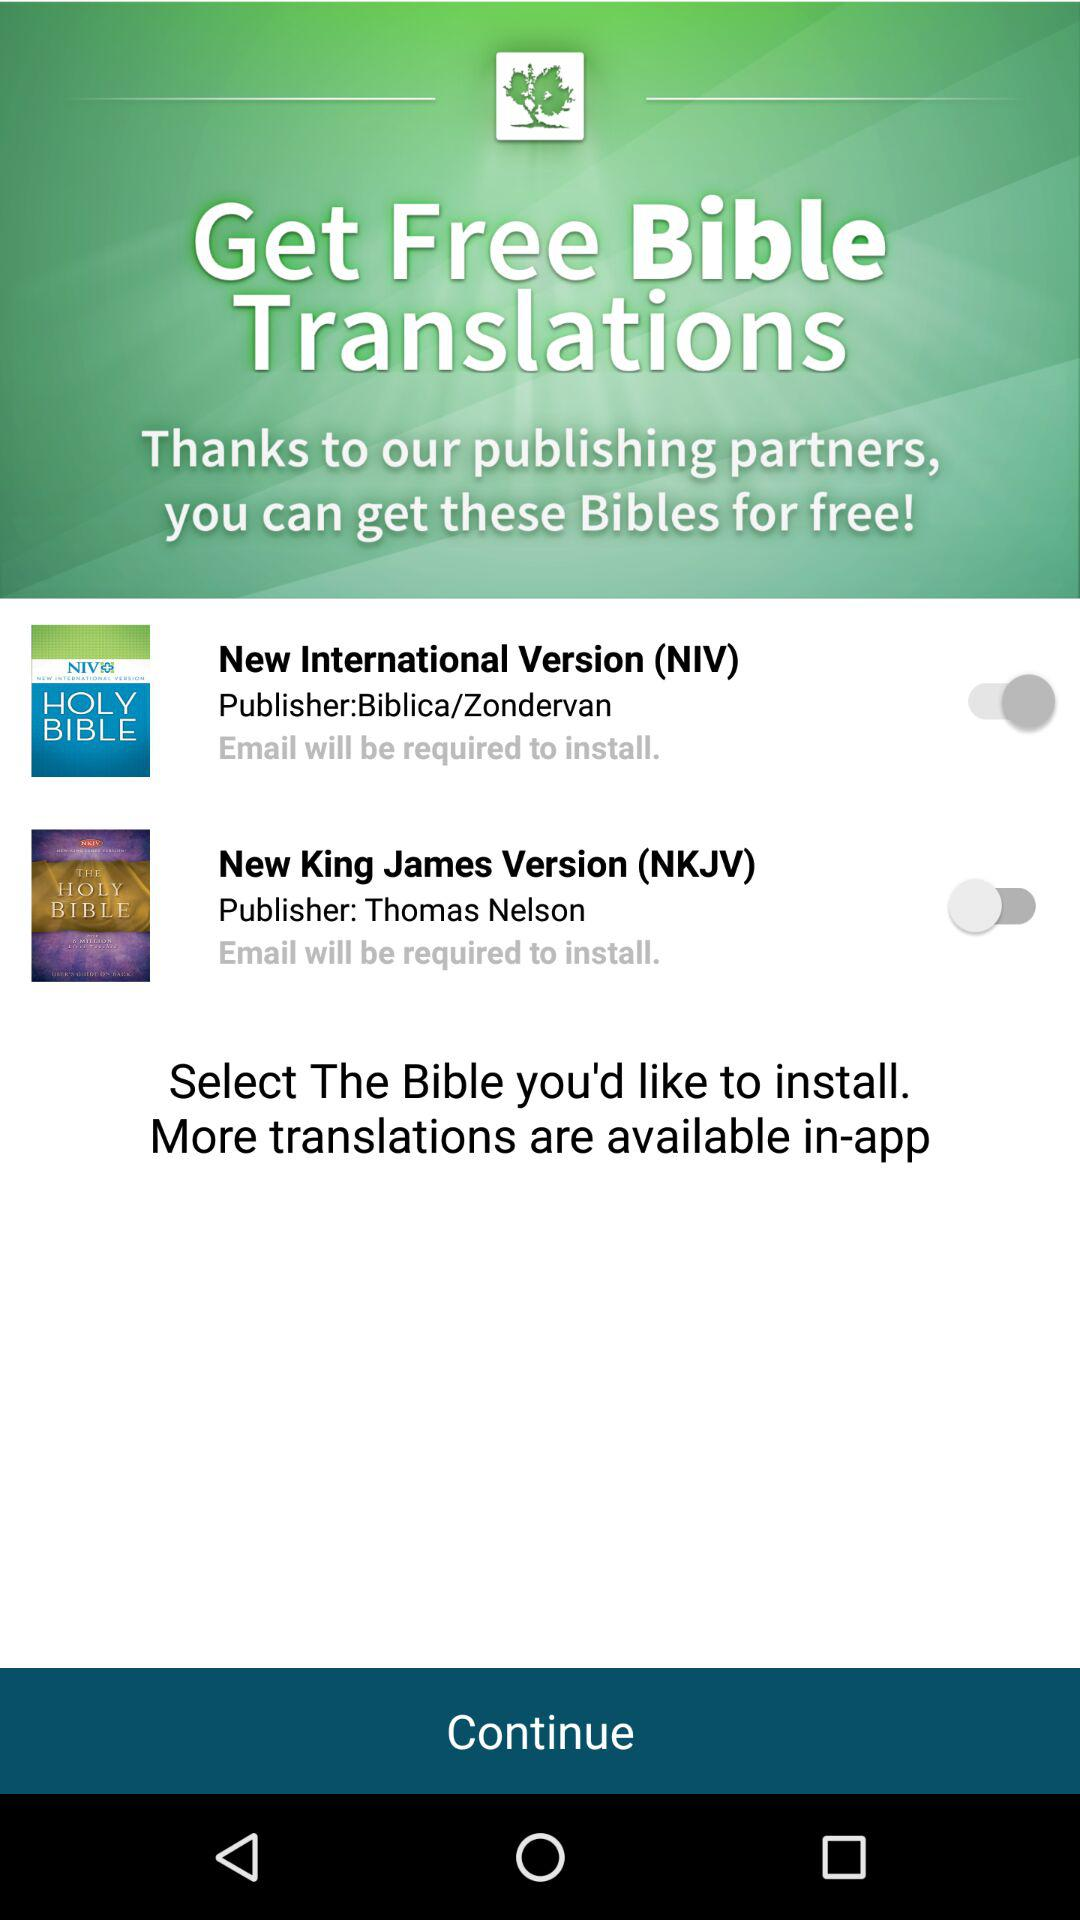Which version is enabled? The enabled version is "New International Version (NIV)". 